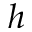<formula> <loc_0><loc_0><loc_500><loc_500>h</formula> 